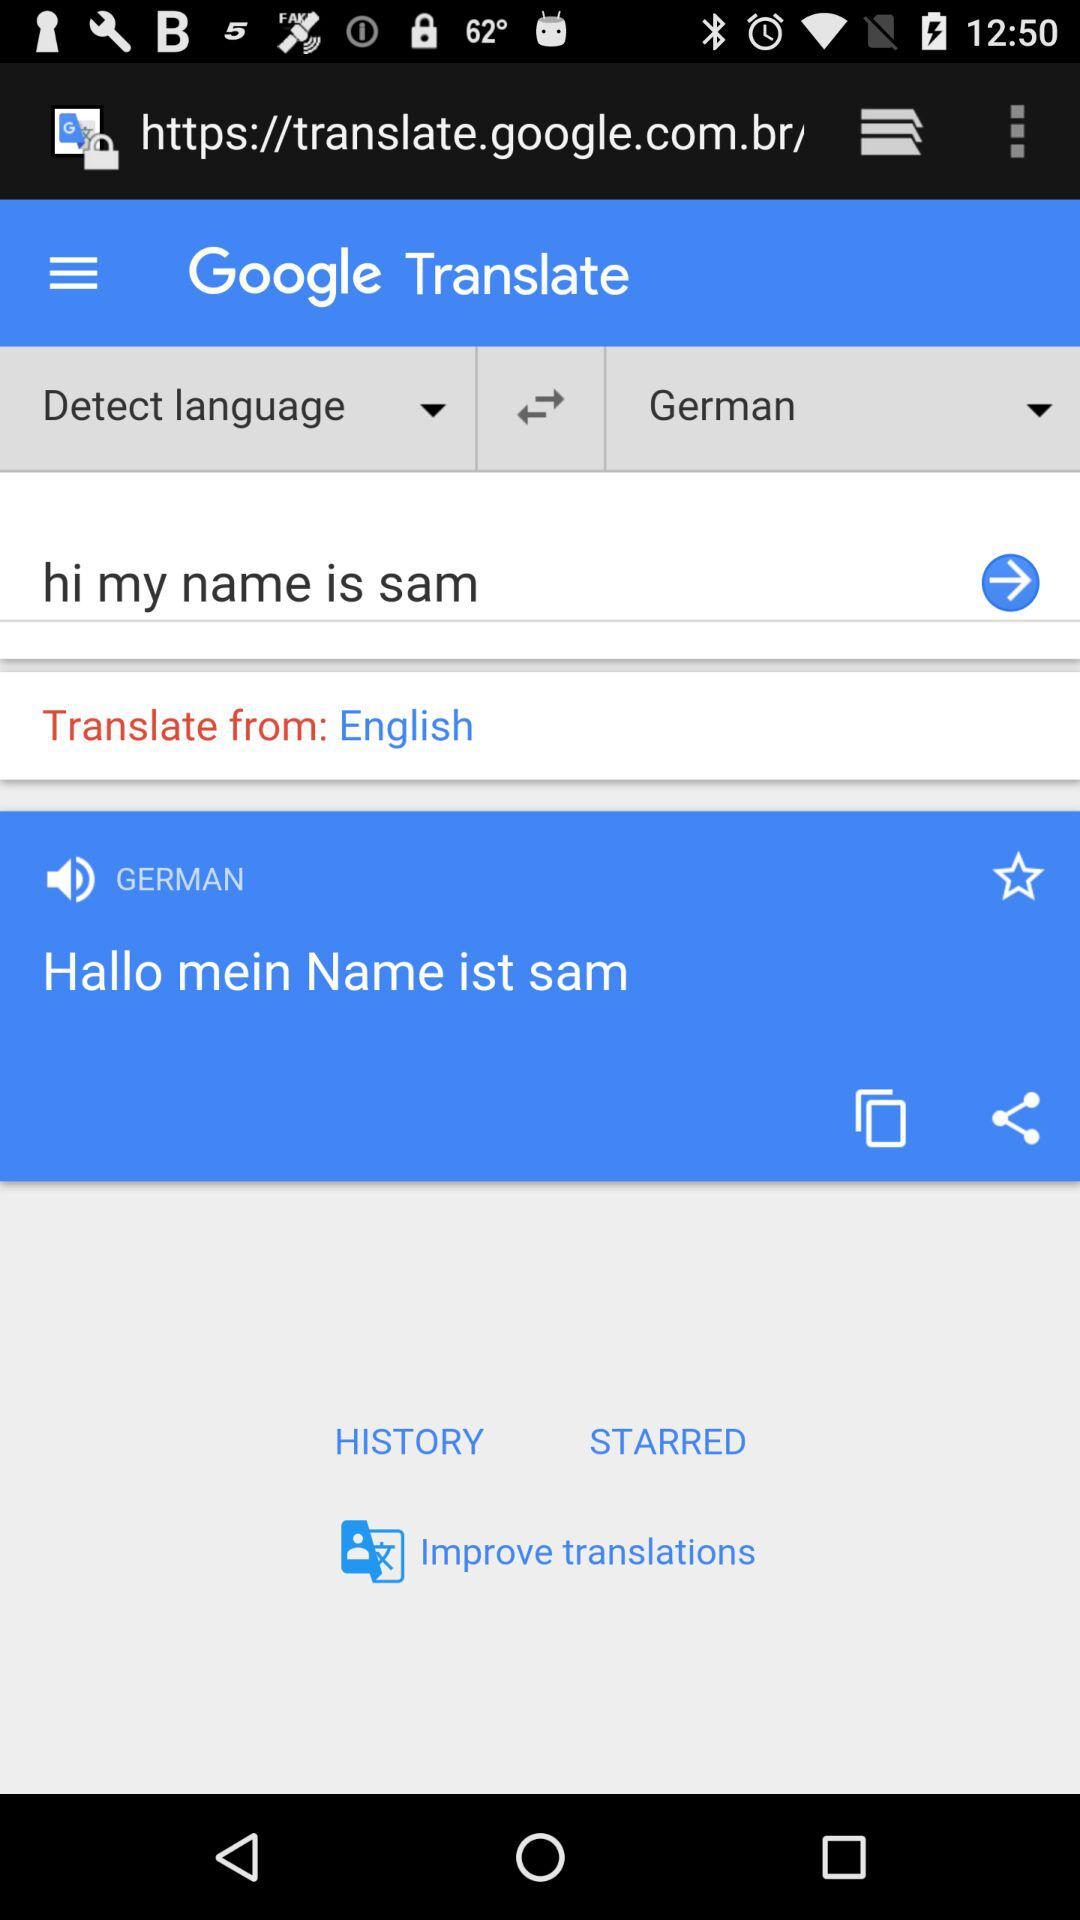Which language was translated to German? The language was English. 